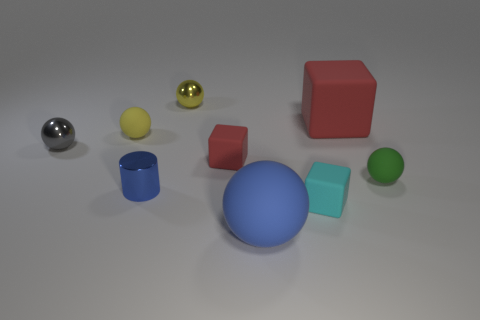The large thing that is behind the tiny matte ball that is on the right side of the yellow object behind the tiny yellow matte thing is made of what material?
Your answer should be compact. Rubber. Is the number of tiny red blocks that are on the right side of the big matte ball greater than the number of big spheres?
Give a very brief answer. No. There is a red object that is the same size as the green thing; what is it made of?
Keep it short and to the point. Rubber. Are there any cyan things of the same size as the cyan block?
Offer a terse response. No. There is a red rubber thing to the right of the large blue thing; what size is it?
Offer a very short reply. Large. The blue cylinder is what size?
Ensure brevity in your answer.  Small. How many cylinders are tiny cyan rubber objects or large gray matte things?
Your response must be concise. 0. There is a yellow thing that is made of the same material as the tiny green object; what is its size?
Your answer should be very brief. Small. How many small matte objects have the same color as the big rubber block?
Offer a very short reply. 1. There is a small gray ball; are there any tiny gray objects left of it?
Make the answer very short. No. 